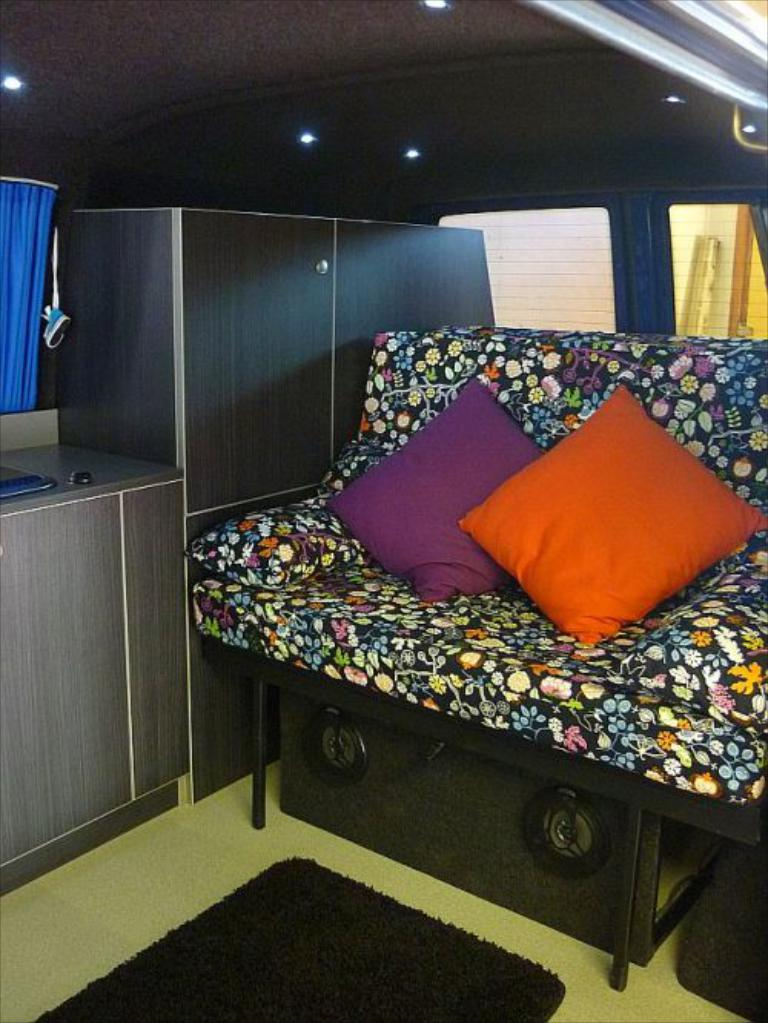What type of furniture is in the image? There is a sofa in the image. What can be seen on the sofa? There are pillows on the sofa. What type of audio equipment is in the image? There are speakers in the image. What type of storage furniture is in the image? There are cupboards in the image. What type of window treatment is in the image? There is a curtain in the image. How many windows are in the image? There are windows in the image. Can you see a band playing music in the image? There is no band playing music in the image. What type of books are on the sofa in the image? There are no books visible in the image. 